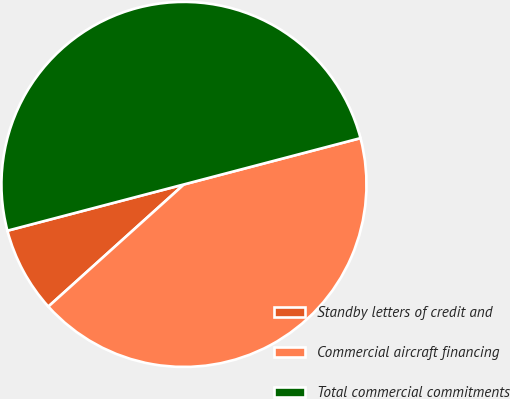Convert chart to OTSL. <chart><loc_0><loc_0><loc_500><loc_500><pie_chart><fcel>Standby letters of credit and<fcel>Commercial aircraft financing<fcel>Total commercial commitments<nl><fcel>7.59%<fcel>42.41%<fcel>50.0%<nl></chart> 